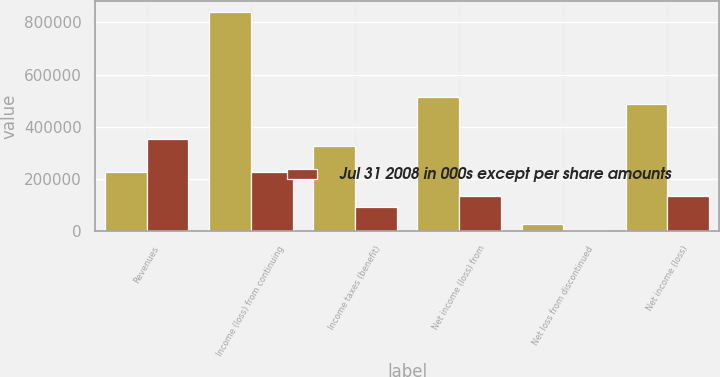Convert chart to OTSL. <chart><loc_0><loc_0><loc_500><loc_500><stacked_bar_chart><ecel><fcel>Revenues<fcel>Income (loss) from continuing<fcel>Income taxes (benefit)<fcel>Net income (loss) from<fcel>Net loss from discontinued<fcel>Net income (loss)<nl><fcel>nan<fcel>227453<fcel>839370<fcel>326315<fcel>513055<fcel>27382<fcel>485673<nl><fcel>Jul 31 2008 in 000s except per share amounts<fcel>351469<fcel>227453<fcel>94292<fcel>133161<fcel>2713<fcel>135874<nl></chart> 